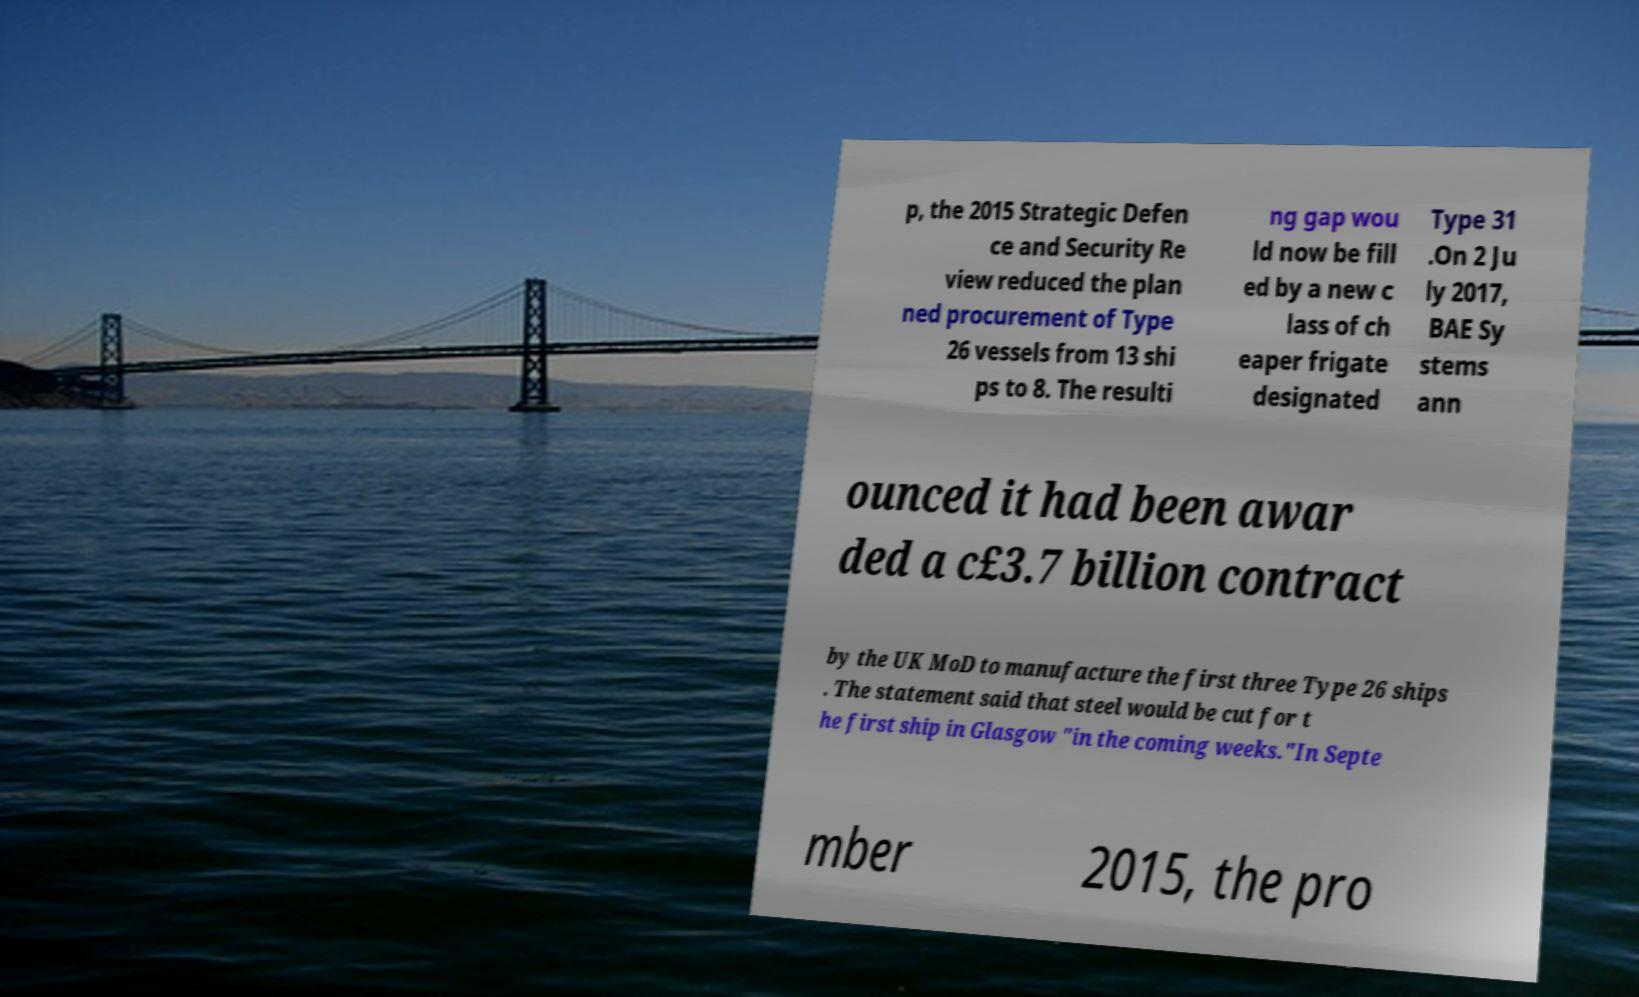For documentation purposes, I need the text within this image transcribed. Could you provide that? p, the 2015 Strategic Defen ce and Security Re view reduced the plan ned procurement of Type 26 vessels from 13 shi ps to 8. The resulti ng gap wou ld now be fill ed by a new c lass of ch eaper frigate designated Type 31 .On 2 Ju ly 2017, BAE Sy stems ann ounced it had been awar ded a c£3.7 billion contract by the UK MoD to manufacture the first three Type 26 ships . The statement said that steel would be cut for t he first ship in Glasgow "in the coming weeks."In Septe mber 2015, the pro 